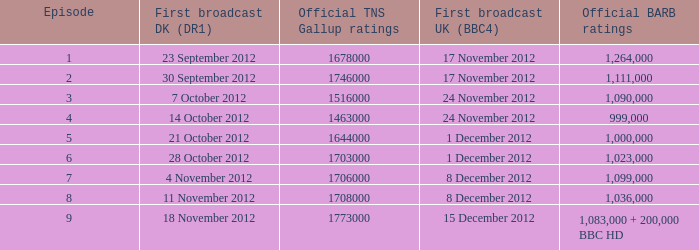When was the episode with a 999,000 BARB rating first aired in Denmark? 14 October 2012. 